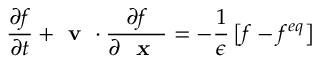<formula> <loc_0><loc_0><loc_500><loc_500>\frac { \partial f } { \partial t } + v \cdot \frac { \partial f } { \partial x } = - \frac { 1 } { \epsilon } \left [ f - f ^ { e q } \right ]</formula> 